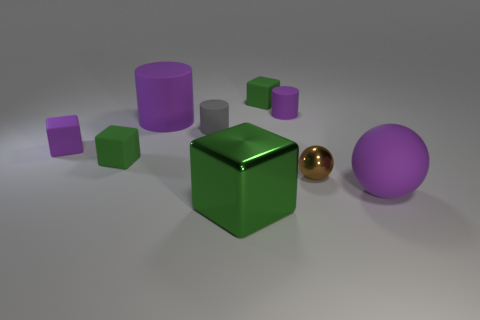Subtract all large green cubes. How many cubes are left? 3 Subtract all cyan balls. How many gray cylinders are left? 1 Add 7 purple balls. How many purple balls exist? 8 Add 1 large red rubber balls. How many objects exist? 10 Subtract all brown spheres. How many spheres are left? 1 Subtract 0 blue cubes. How many objects are left? 9 Subtract all cubes. How many objects are left? 5 Subtract 1 cylinders. How many cylinders are left? 2 Subtract all blue blocks. Subtract all brown balls. How many blocks are left? 4 Subtract all small gray matte objects. Subtract all large objects. How many objects are left? 5 